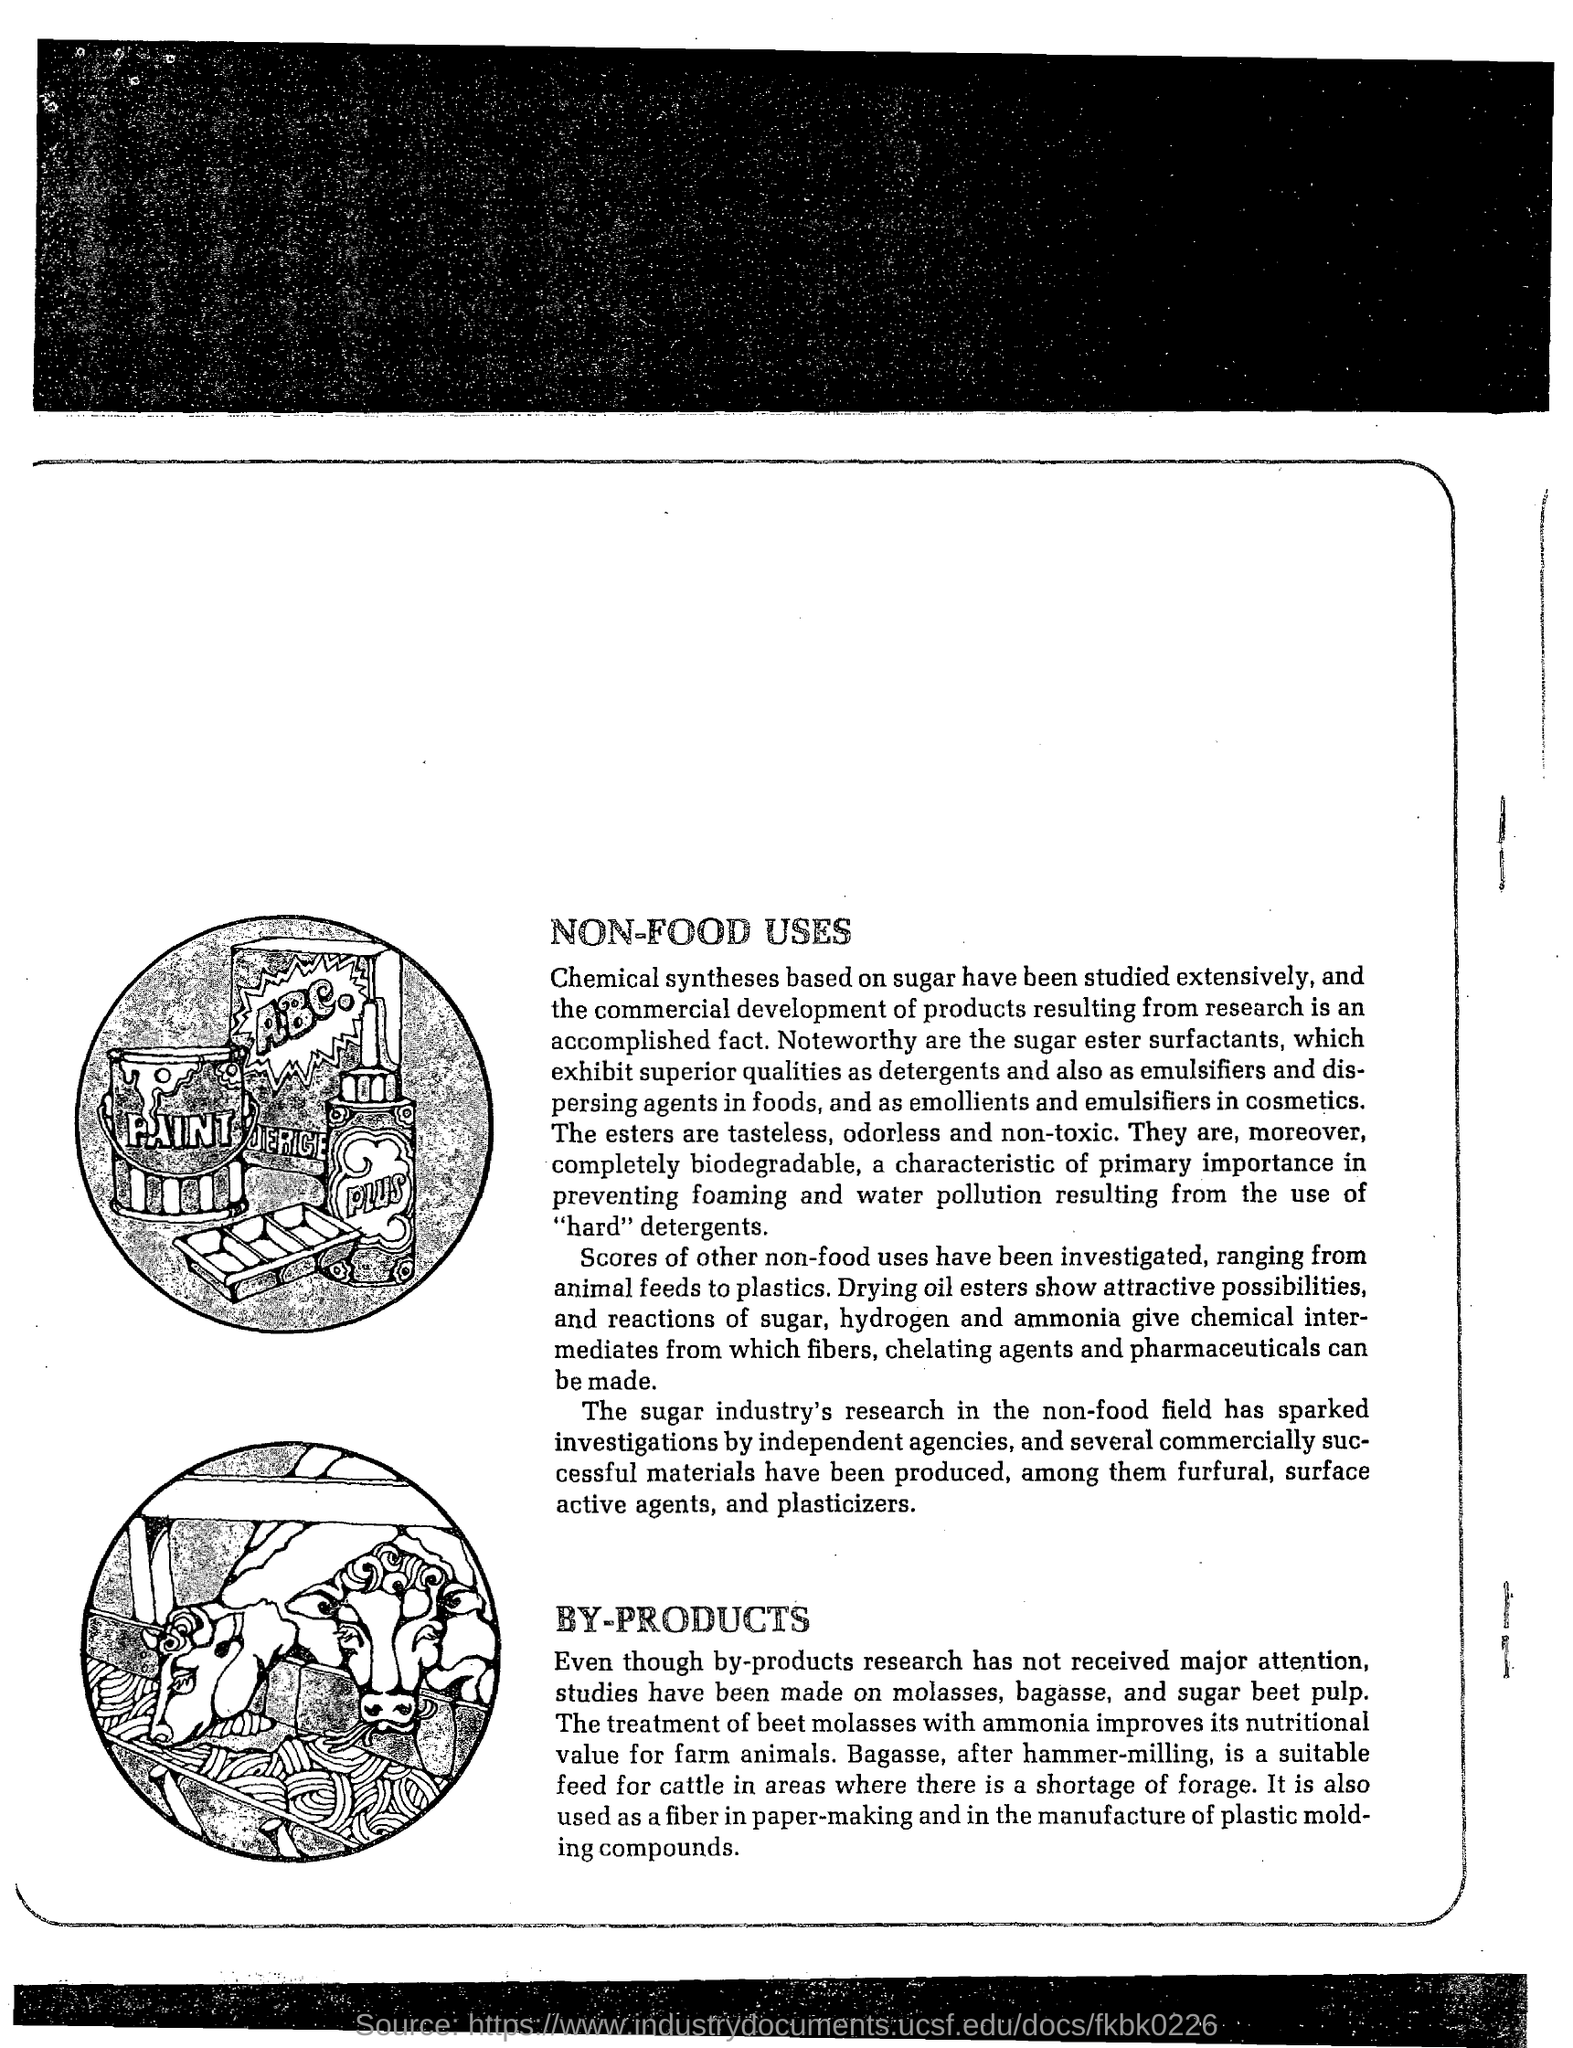What can be used as detergents and emulsifiers?
Offer a terse response. Sugar ester surfactants. The treatment of beet molasses with what improves its nutritional value for farm animals?
Provide a short and direct response. Ammonia. What is a suitable feed for cattle after hammer-milling?
Make the answer very short. Bagasse. 